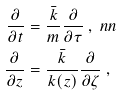<formula> <loc_0><loc_0><loc_500><loc_500>\frac { \partial } { \partial t } & = \frac { \bar { k } } { m } \frac { \partial } { \partial \tau } \ , \ n n \\ \frac { \partial } { \partial z } & = \frac { \bar { k } } { k ( z ) } \frac { \partial } { \partial \zeta } \ ,</formula> 